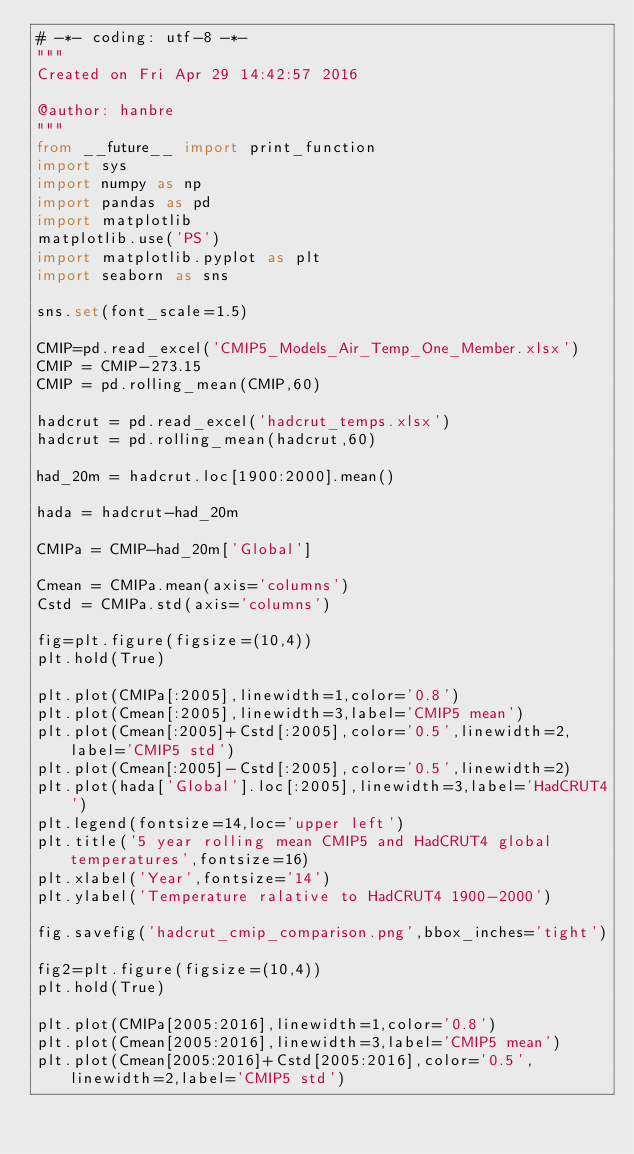<code> <loc_0><loc_0><loc_500><loc_500><_Python_># -*- coding: utf-8 -*-
"""
Created on Fri Apr 29 14:42:57 2016

@author: hanbre
"""
from __future__ import print_function
import sys
import numpy as np
import pandas as pd
import matplotlib
matplotlib.use('PS')
import matplotlib.pyplot as plt
import seaborn as sns

sns.set(font_scale=1.5)

CMIP=pd.read_excel('CMIP5_Models_Air_Temp_One_Member.xlsx')
CMIP = CMIP-273.15
CMIP = pd.rolling_mean(CMIP,60)

hadcrut = pd.read_excel('hadcrut_temps.xlsx')
hadcrut = pd.rolling_mean(hadcrut,60)

had_20m = hadcrut.loc[1900:2000].mean()

hada = hadcrut-had_20m

CMIPa = CMIP-had_20m['Global']

Cmean = CMIPa.mean(axis='columns')
Cstd = CMIPa.std(axis='columns')

fig=plt.figure(figsize=(10,4))
plt.hold(True)

plt.plot(CMIPa[:2005],linewidth=1,color='0.8')
plt.plot(Cmean[:2005],linewidth=3,label='CMIP5 mean')
plt.plot(Cmean[:2005]+Cstd[:2005],color='0.5',linewidth=2,label='CMIP5 std')
plt.plot(Cmean[:2005]-Cstd[:2005],color='0.5',linewidth=2)
plt.plot(hada['Global'].loc[:2005],linewidth=3,label='HadCRUT4')
plt.legend(fontsize=14,loc='upper left')
plt.title('5 year rolling mean CMIP5 and HadCRUT4 global temperatures',fontsize=16)
plt.xlabel('Year',fontsize='14')
plt.ylabel('Temperature ralative to HadCRUT4 1900-2000')

fig.savefig('hadcrut_cmip_comparison.png',bbox_inches='tight')

fig2=plt.figure(figsize=(10,4))
plt.hold(True)

plt.plot(CMIPa[2005:2016],linewidth=1,color='0.8')
plt.plot(Cmean[2005:2016],linewidth=3,label='CMIP5 mean')
plt.plot(Cmean[2005:2016]+Cstd[2005:2016],color='0.5',linewidth=2,label='CMIP5 std')</code> 